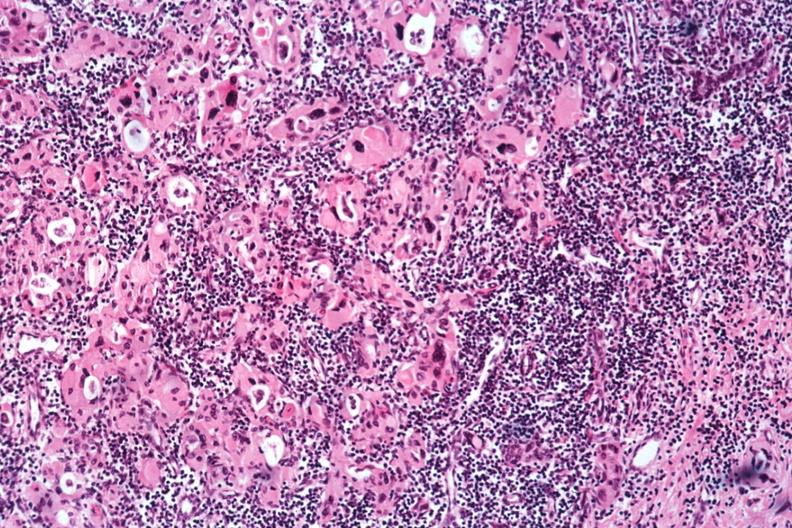s infant body present?
Answer the question using a single word or phrase. No 